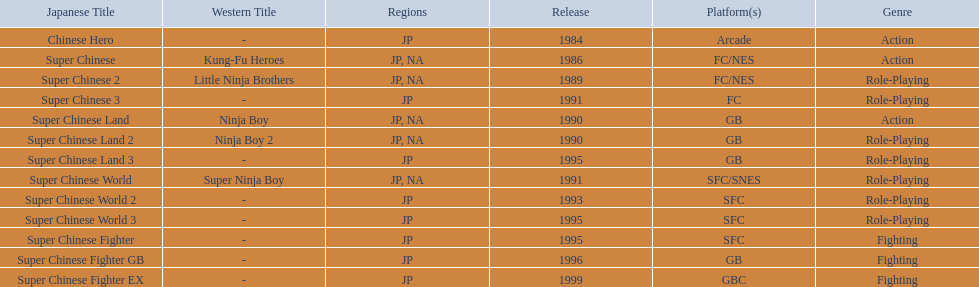Which japanese titles were launched in the north american (na) region? Super Chinese, Super Chinese 2, Super Chinese Land, Super Chinese Land 2, Super Chinese World. Among them, which one was introduced most recently? Super Chinese World. 